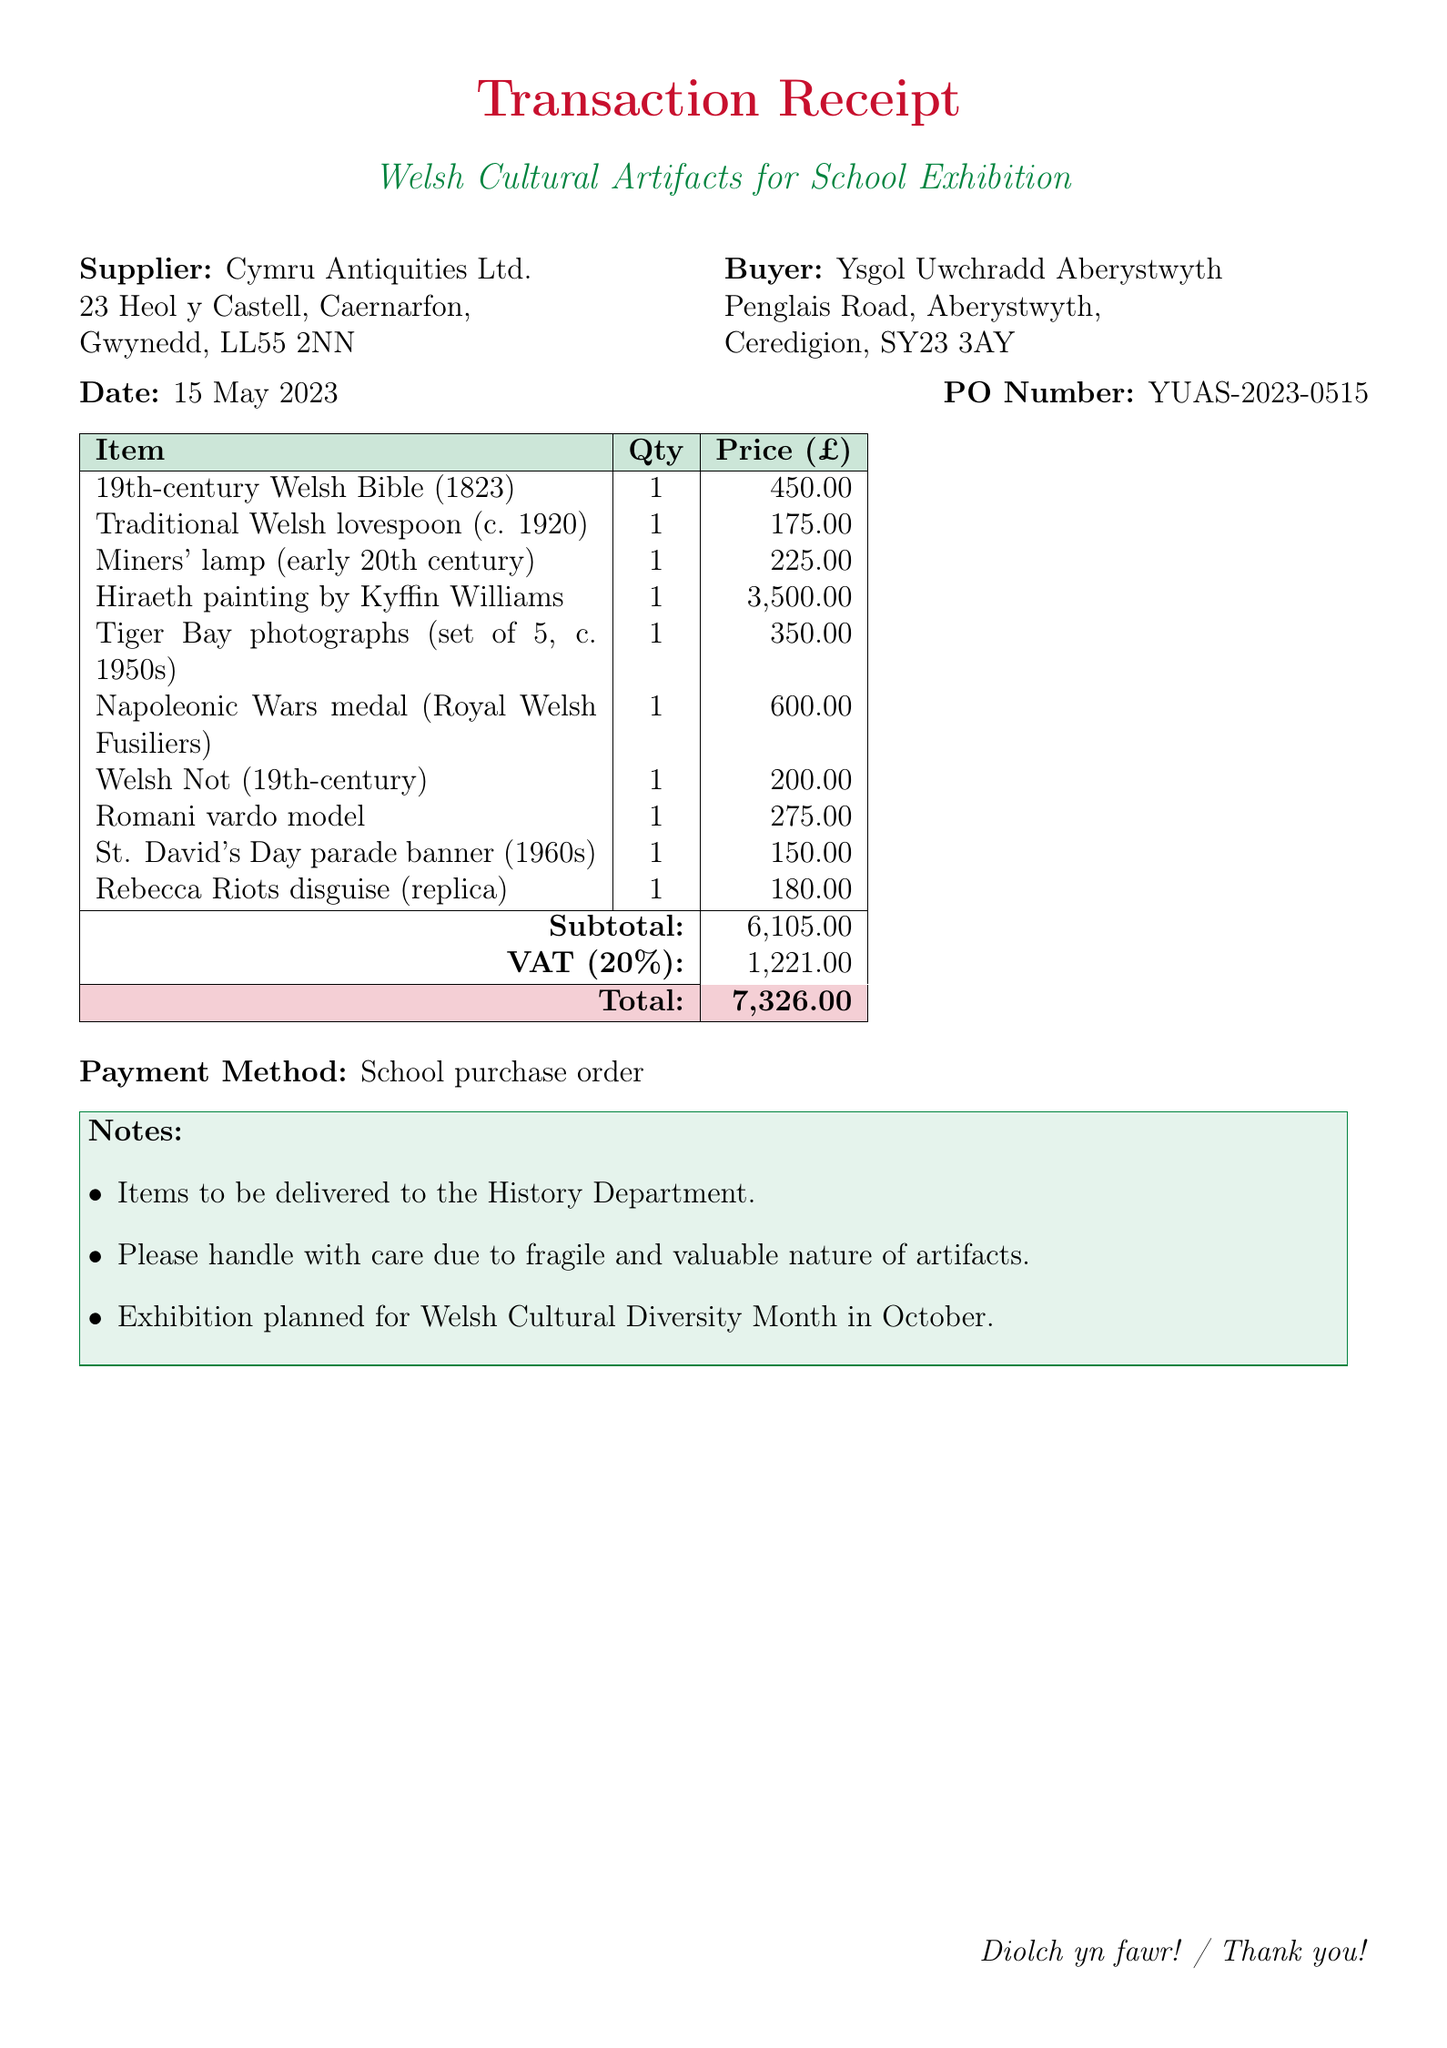What is the transaction date? The document specifies the date when the transaction occurred, which is listed as 15 May 2023.
Answer: 15 May 2023 What is the total amount spent? The total amount listed at the end of the document summarizes the overall expenditure, including VAT, which is 7,326.00.
Answer: 7,326.00 Who is the supplier? The document indicates the name of the organization from which the artifacts were purchased, which is Cymru Antiquities Ltd.
Answer: Cymru Antiquities Ltd How many items were purchased in total? The document lists individual items, with a total number of items being 10, each listed separately.
Answer: 10 What is the subtotal before VAT? The subtotal before tax is provided in the document, summing up the cost of all items, which is stated as 6,105.00.
Answer: 6,105.00 What is the purpose of the exhibition? The notes section of the document mentions the exhibition's focus on showcasing Welsh cultural diversity.
Answer: Welsh Cultural Diversity Month What describes the item 'Hiraeth painting'? The description provided in the document states it is an oil painting depicting a Welsh landscape by Kyffin Williams.
Answer: Oil painting depicting Welsh landscape by Kyffin Williams How will the items be delivered? The notes clarify that items are to be delivered to the History Department, emphasizing handling care.
Answer: History Department What is the payment method used for this transaction? The document specifies the payment method used for this purchase is a school purchase order.
Answer: School purchase order 